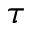<formula> <loc_0><loc_0><loc_500><loc_500>\tau</formula> 